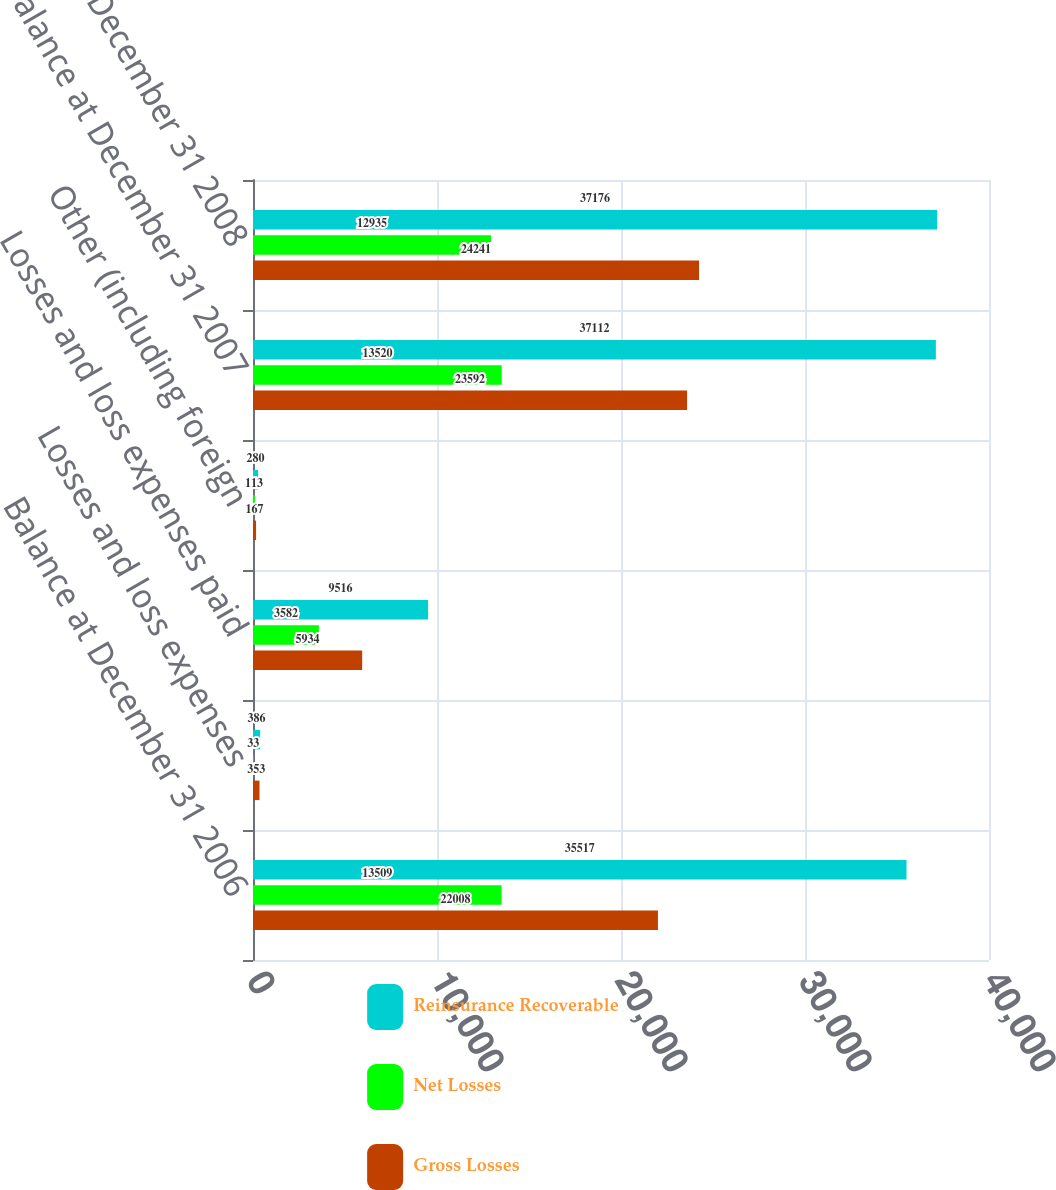Convert chart. <chart><loc_0><loc_0><loc_500><loc_500><stacked_bar_chart><ecel><fcel>Balance at December 31 2006<fcel>Losses and loss expenses<fcel>Losses and loss expenses paid<fcel>Other (including foreign<fcel>Balance at December 31 2007<fcel>Balance at December 31 2008<nl><fcel>Reinsurance Recoverable<fcel>35517<fcel>386<fcel>9516<fcel>280<fcel>37112<fcel>37176<nl><fcel>Net Losses<fcel>13509<fcel>33<fcel>3582<fcel>113<fcel>13520<fcel>12935<nl><fcel>Gross Losses<fcel>22008<fcel>353<fcel>5934<fcel>167<fcel>23592<fcel>24241<nl></chart> 